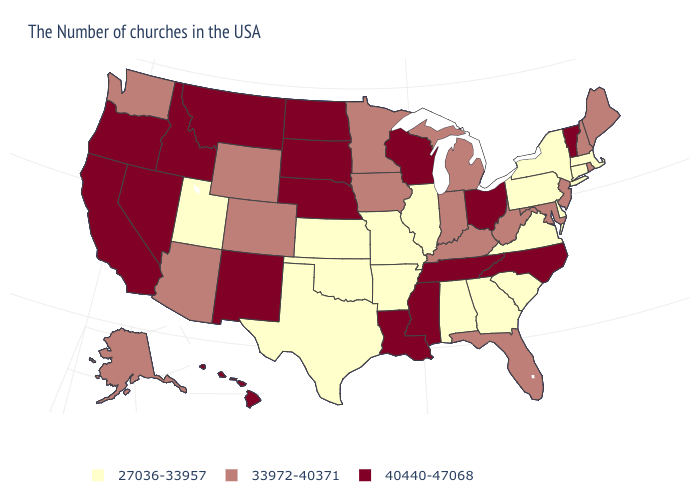What is the value of Wyoming?
Give a very brief answer. 33972-40371. Which states have the lowest value in the USA?
Write a very short answer. Massachusetts, Connecticut, New York, Delaware, Pennsylvania, Virginia, South Carolina, Georgia, Alabama, Illinois, Missouri, Arkansas, Kansas, Oklahoma, Texas, Utah. Name the states that have a value in the range 27036-33957?
Be succinct. Massachusetts, Connecticut, New York, Delaware, Pennsylvania, Virginia, South Carolina, Georgia, Alabama, Illinois, Missouri, Arkansas, Kansas, Oklahoma, Texas, Utah. What is the value of Michigan?
Write a very short answer. 33972-40371. What is the value of Michigan?
Give a very brief answer. 33972-40371. Name the states that have a value in the range 33972-40371?
Give a very brief answer. Maine, Rhode Island, New Hampshire, New Jersey, Maryland, West Virginia, Florida, Michigan, Kentucky, Indiana, Minnesota, Iowa, Wyoming, Colorado, Arizona, Washington, Alaska. Name the states that have a value in the range 27036-33957?
Keep it brief. Massachusetts, Connecticut, New York, Delaware, Pennsylvania, Virginia, South Carolina, Georgia, Alabama, Illinois, Missouri, Arkansas, Kansas, Oklahoma, Texas, Utah. What is the lowest value in states that border Arkansas?
Short answer required. 27036-33957. Which states have the lowest value in the USA?
Quick response, please. Massachusetts, Connecticut, New York, Delaware, Pennsylvania, Virginia, South Carolina, Georgia, Alabama, Illinois, Missouri, Arkansas, Kansas, Oklahoma, Texas, Utah. What is the lowest value in states that border Kansas?
Short answer required. 27036-33957. Which states have the highest value in the USA?
Write a very short answer. Vermont, North Carolina, Ohio, Tennessee, Wisconsin, Mississippi, Louisiana, Nebraska, South Dakota, North Dakota, New Mexico, Montana, Idaho, Nevada, California, Oregon, Hawaii. Among the states that border Nevada , does Utah have the lowest value?
Be succinct. Yes. What is the lowest value in the USA?
Be succinct. 27036-33957. What is the value of North Carolina?
Keep it brief. 40440-47068. What is the lowest value in the USA?
Keep it brief. 27036-33957. 